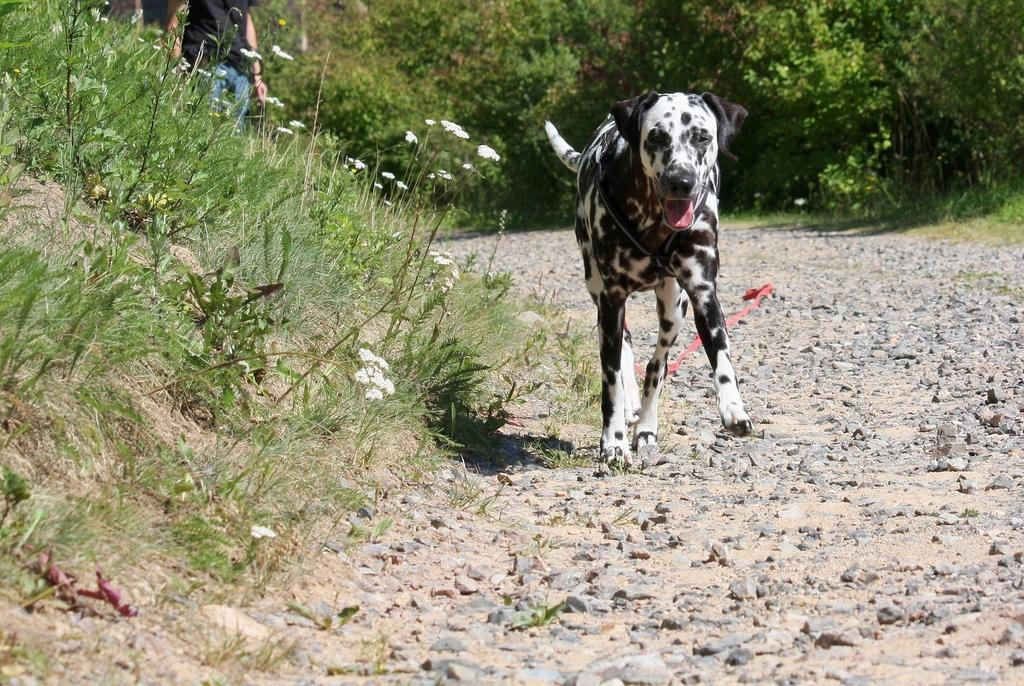What animal can be seen in the image? There is a dog in the image. What is the dog doing in the image? The dog is running on the street. What can be seen on the left side of the image? There are white flowers on plants on the left side of the image. What is visible in the background of the image? There are many trees, plants, and grass in the background of the image. What holiday is the writer celebrating in the image? There is no writer or holiday mentioned or depicted in the image. What type of bushes are present in the image? There is no mention of bushes in the image; it features a dog running on the street, white flowers on plants on the left side, and a background with many trees, plants, and grass. 